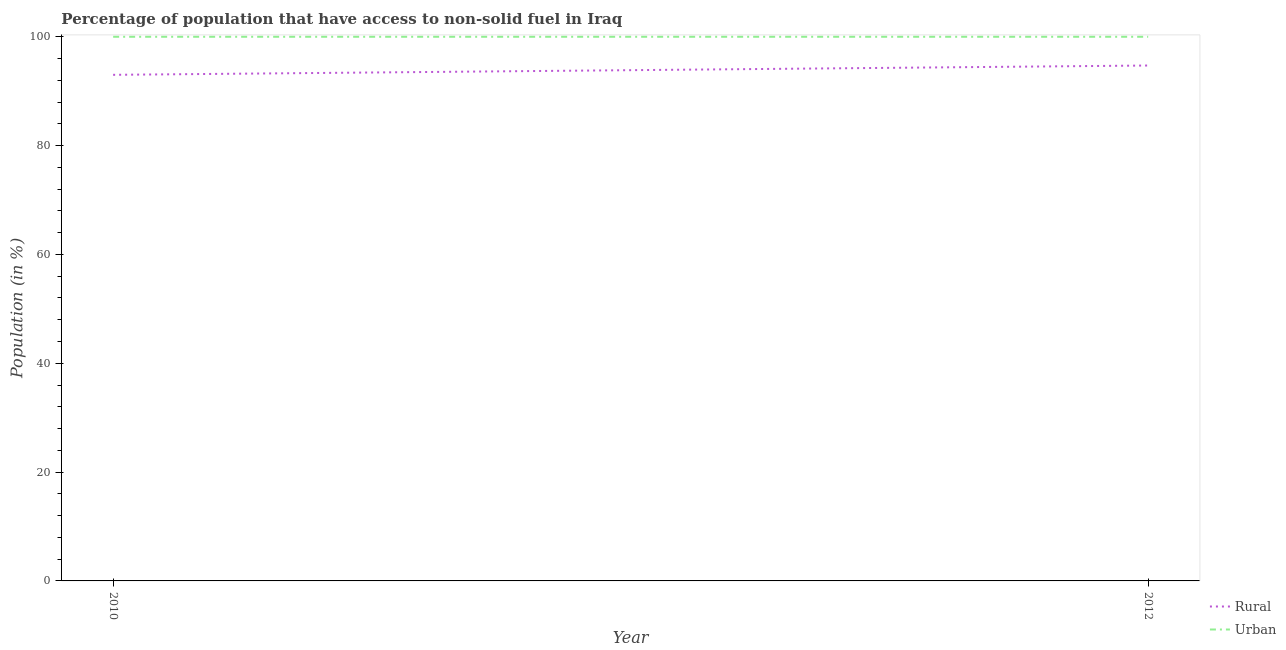How many different coloured lines are there?
Provide a short and direct response. 2. Does the line corresponding to urban population intersect with the line corresponding to rural population?
Give a very brief answer. No. Is the number of lines equal to the number of legend labels?
Keep it short and to the point. Yes. What is the urban population in 2010?
Your response must be concise. 100. Across all years, what is the maximum rural population?
Offer a terse response. 94.72. Across all years, what is the minimum rural population?
Offer a terse response. 93.01. In which year was the rural population minimum?
Your answer should be compact. 2010. What is the total urban population in the graph?
Offer a very short reply. 200. What is the difference between the rural population in 2010 and that in 2012?
Give a very brief answer. -1.71. What is the difference between the urban population in 2012 and the rural population in 2010?
Make the answer very short. 6.99. What is the average rural population per year?
Provide a succinct answer. 93.86. In the year 2010, what is the difference between the urban population and rural population?
Offer a very short reply. 6.99. In how many years, is the rural population greater than 44 %?
Ensure brevity in your answer.  2. What is the ratio of the rural population in 2010 to that in 2012?
Your response must be concise. 0.98. Is the rural population in 2010 less than that in 2012?
Make the answer very short. Yes. In how many years, is the urban population greater than the average urban population taken over all years?
Provide a succinct answer. 0. Does the rural population monotonically increase over the years?
Make the answer very short. Yes. Is the urban population strictly greater than the rural population over the years?
Give a very brief answer. Yes. Is the rural population strictly less than the urban population over the years?
Provide a short and direct response. Yes. How many years are there in the graph?
Offer a terse response. 2. What is the difference between two consecutive major ticks on the Y-axis?
Offer a very short reply. 20. Are the values on the major ticks of Y-axis written in scientific E-notation?
Provide a succinct answer. No. How many legend labels are there?
Provide a succinct answer. 2. What is the title of the graph?
Offer a very short reply. Percentage of population that have access to non-solid fuel in Iraq. What is the label or title of the X-axis?
Your response must be concise. Year. What is the label or title of the Y-axis?
Give a very brief answer. Population (in %). What is the Population (in %) of Rural in 2010?
Provide a short and direct response. 93.01. What is the Population (in %) in Rural in 2012?
Offer a terse response. 94.72. Across all years, what is the maximum Population (in %) of Rural?
Make the answer very short. 94.72. Across all years, what is the minimum Population (in %) of Rural?
Ensure brevity in your answer.  93.01. Across all years, what is the minimum Population (in %) of Urban?
Keep it short and to the point. 100. What is the total Population (in %) of Rural in the graph?
Your answer should be compact. 187.72. What is the total Population (in %) in Urban in the graph?
Provide a short and direct response. 200. What is the difference between the Population (in %) of Rural in 2010 and that in 2012?
Keep it short and to the point. -1.71. What is the difference between the Population (in %) in Rural in 2010 and the Population (in %) in Urban in 2012?
Your response must be concise. -6.99. What is the average Population (in %) of Rural per year?
Keep it short and to the point. 93.86. What is the average Population (in %) in Urban per year?
Keep it short and to the point. 100. In the year 2010, what is the difference between the Population (in %) in Rural and Population (in %) in Urban?
Your answer should be compact. -6.99. In the year 2012, what is the difference between the Population (in %) in Rural and Population (in %) in Urban?
Your answer should be very brief. -5.28. What is the ratio of the Population (in %) of Rural in 2010 to that in 2012?
Ensure brevity in your answer.  0.98. What is the ratio of the Population (in %) in Urban in 2010 to that in 2012?
Your response must be concise. 1. What is the difference between the highest and the second highest Population (in %) of Rural?
Give a very brief answer. 1.71. What is the difference between the highest and the lowest Population (in %) in Rural?
Provide a short and direct response. 1.71. 